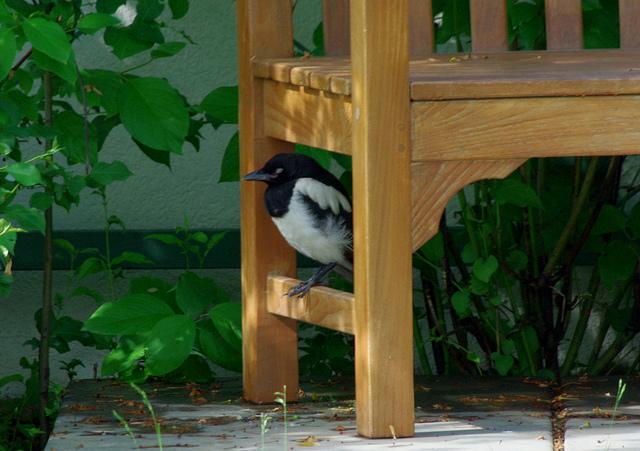Is this animal contained?
Answer briefly. No. What animal is in the picture?
Short answer required. Bird. Is the bird in motion?
Short answer required. No. Is the bird facing left or right?
Be succinct. Left. 